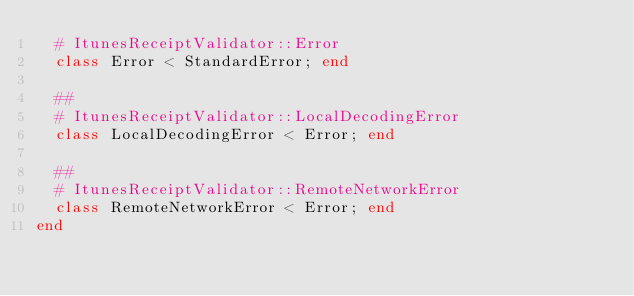<code> <loc_0><loc_0><loc_500><loc_500><_Ruby_>  # ItunesReceiptValidator::Error
  class Error < StandardError; end

  ##
  # ItunesReceiptValidator::LocalDecodingError
  class LocalDecodingError < Error; end

  ##
  # ItunesReceiptValidator::RemoteNetworkError
  class RemoteNetworkError < Error; end
end
</code> 